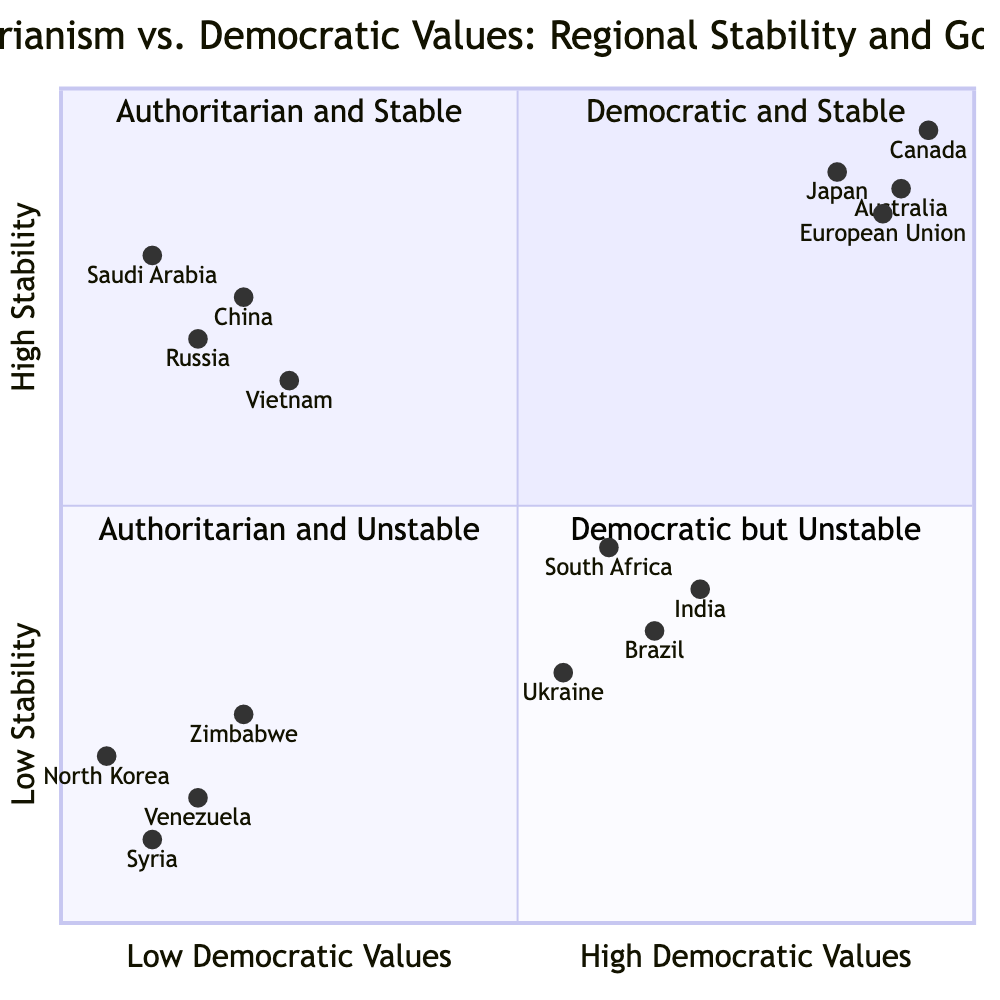What examples are in the Democratic and Stable quadrant? In the diagram, the Democratic and Stable quadrant contains specific examples of countries such as the European Union, Japan, Canada, and Australia. These countries are located in the quadrant representing high democratic values and high stability.
Answer: European Union, Japan, Canada, Australia How many countries are categorized as Authoritarian and Unstable? By examining the Authoritarian and Unstable quadrant in the diagram, we find a total of four countries listed: North Korea, Syria, Venezuela, and Zimbabwe. The count is achieved by identifying each unique example provided in this section.
Answer: 4 What characteristic is shared by countries in both Authoritarian quadrants? The shared characteristic between the Authoritarian and Stable and Authoritarian and Unstable quadrants is "Centralized Power Structures." This can be identified by analyzing the characteristics listed under both quadrants and recognizing the commonality.
Answer: Centralized Power Structures Which region exhibits high political participation but is marked by political corruption? The quadrant displaying these traits is Democratic but Unstable, where countries like India, Brazil, South Africa, and Ukraine are found. The contradiction comes from high political participation alongside issues like political corruption.
Answer: India, Brazil, South Africa, Ukraine What is the political stability of China according to the diagram? The diagram places China in the Authoritarian and Stable quadrant, indicating that it has a level of stability categorized as high, despite the low democratic values. This conclusion is drawn from the location of China within the quadrant based on its position.
Answer: High What is the main economic condition shared by countries in the Authoritarian and Unstable quadrant? The countries found in this quadrant, such as North Korea, Syria, Venezuela, and Zimbabwe, exhibit "Economic Decline" as a shared characteristic. By scrutinizing the features provided, this characteristic is identified as common among them.
Answer: Economic Decline Which country is the least stable based on the diagram? North Korea, positioned at [0.05, 0.2] in the Authoritarian and Unstable quadrant, is the least stable according to the coordinates assigned to it that indicate low stability. This is determined by comparing the stability values of all countries in the diagram.
Answer: North Korea What is the political situation in Brazil according to this chart? Brazil is categorized under the Democratic but Unstable quadrant, where it has a weak institutional framework, alongside issues related to political corruption, which makes it unstable despite being democratic. This classification comes from Brazil's specific coordinates and characteristics listed.
Answer: Weak Institutional Frameworks What feature distinguishes the Democratic and Stable quadrant from the Authoritarian quadrants? The distinguishing feature is "Transparent Governance," which is characteristic of countries in the Democratic and Stable quadrant, unlike the Authoritarian quadrants, which feature limited political freedoms. This is determined by analyzing the characteristics assigned to each quadrant.
Answer: Transparent Governance 